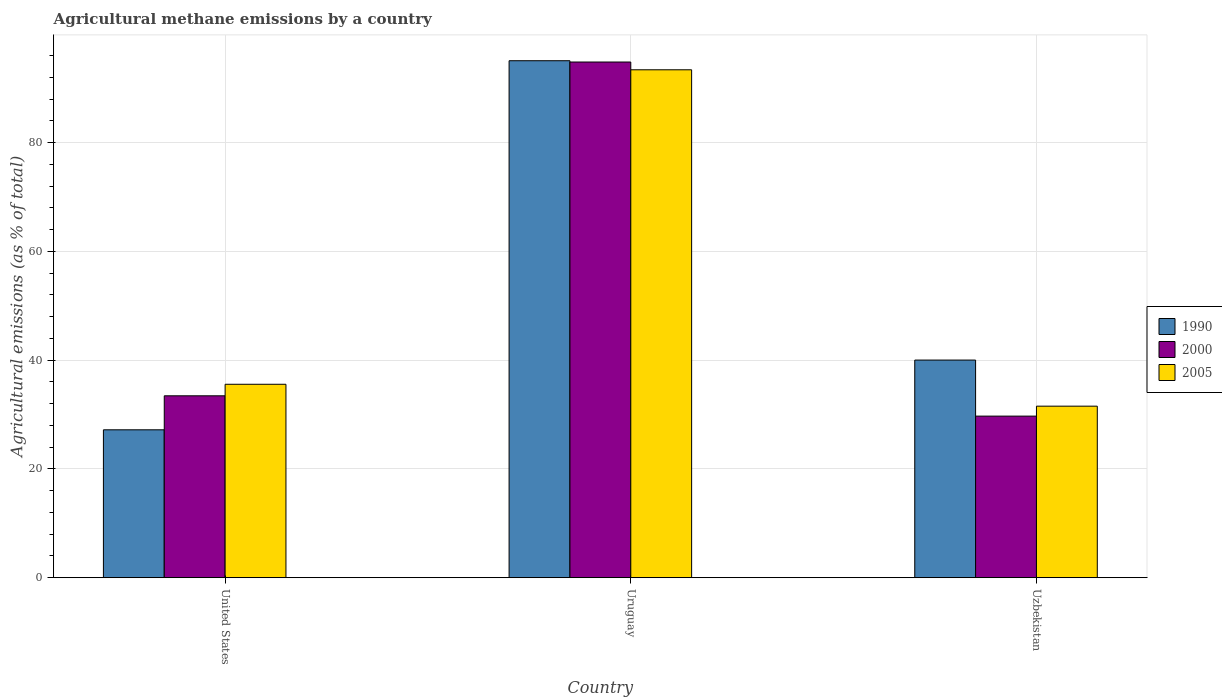Are the number of bars per tick equal to the number of legend labels?
Your answer should be compact. Yes. Are the number of bars on each tick of the X-axis equal?
Provide a succinct answer. Yes. How many bars are there on the 3rd tick from the left?
Your response must be concise. 3. How many bars are there on the 2nd tick from the right?
Your answer should be compact. 3. What is the label of the 2nd group of bars from the left?
Keep it short and to the point. Uruguay. What is the amount of agricultural methane emitted in 2005 in Uzbekistan?
Provide a succinct answer. 31.54. Across all countries, what is the maximum amount of agricultural methane emitted in 1990?
Offer a terse response. 95.06. Across all countries, what is the minimum amount of agricultural methane emitted in 2005?
Offer a terse response. 31.54. In which country was the amount of agricultural methane emitted in 1990 maximum?
Your response must be concise. Uruguay. In which country was the amount of agricultural methane emitted in 1990 minimum?
Offer a very short reply. United States. What is the total amount of agricultural methane emitted in 1990 in the graph?
Provide a short and direct response. 162.27. What is the difference between the amount of agricultural methane emitted in 1990 in United States and that in Uzbekistan?
Your answer should be very brief. -12.82. What is the difference between the amount of agricultural methane emitted in 2005 in United States and the amount of agricultural methane emitted in 2000 in Uzbekistan?
Offer a terse response. 5.85. What is the average amount of agricultural methane emitted in 1990 per country?
Your answer should be compact. 54.09. What is the difference between the amount of agricultural methane emitted of/in 2000 and amount of agricultural methane emitted of/in 1990 in Uzbekistan?
Ensure brevity in your answer.  -10.31. In how many countries, is the amount of agricultural methane emitted in 2000 greater than 28 %?
Offer a terse response. 3. What is the ratio of the amount of agricultural methane emitted in 2000 in United States to that in Uruguay?
Your answer should be compact. 0.35. Is the amount of agricultural methane emitted in 2000 in United States less than that in Uzbekistan?
Provide a succinct answer. No. What is the difference between the highest and the second highest amount of agricultural methane emitted in 2005?
Offer a very short reply. -57.82. What is the difference between the highest and the lowest amount of agricultural methane emitted in 1990?
Offer a terse response. 67.86. In how many countries, is the amount of agricultural methane emitted in 2000 greater than the average amount of agricultural methane emitted in 2000 taken over all countries?
Offer a very short reply. 1. Is the sum of the amount of agricultural methane emitted in 1990 in United States and Uzbekistan greater than the maximum amount of agricultural methane emitted in 2000 across all countries?
Make the answer very short. No. What does the 3rd bar from the left in United States represents?
Give a very brief answer. 2005. Is it the case that in every country, the sum of the amount of agricultural methane emitted in 2005 and amount of agricultural methane emitted in 1990 is greater than the amount of agricultural methane emitted in 2000?
Offer a terse response. Yes. How many bars are there?
Keep it short and to the point. 9. Are all the bars in the graph horizontal?
Give a very brief answer. No. What is the difference between two consecutive major ticks on the Y-axis?
Ensure brevity in your answer.  20. Are the values on the major ticks of Y-axis written in scientific E-notation?
Provide a succinct answer. No. Does the graph contain any zero values?
Provide a short and direct response. No. How are the legend labels stacked?
Offer a terse response. Vertical. What is the title of the graph?
Your answer should be very brief. Agricultural methane emissions by a country. Does "1962" appear as one of the legend labels in the graph?
Offer a very short reply. No. What is the label or title of the Y-axis?
Make the answer very short. Agricultural emissions (as % of total). What is the Agricultural emissions (as % of total) in 1990 in United States?
Your response must be concise. 27.19. What is the Agricultural emissions (as % of total) in 2000 in United States?
Offer a very short reply. 33.45. What is the Agricultural emissions (as % of total) of 2005 in United States?
Offer a terse response. 35.56. What is the Agricultural emissions (as % of total) in 1990 in Uruguay?
Ensure brevity in your answer.  95.06. What is the Agricultural emissions (as % of total) in 2000 in Uruguay?
Ensure brevity in your answer.  94.82. What is the Agricultural emissions (as % of total) in 2005 in Uruguay?
Provide a short and direct response. 93.39. What is the Agricultural emissions (as % of total) of 1990 in Uzbekistan?
Offer a very short reply. 40.02. What is the Agricultural emissions (as % of total) in 2000 in Uzbekistan?
Provide a succinct answer. 29.71. What is the Agricultural emissions (as % of total) of 2005 in Uzbekistan?
Give a very brief answer. 31.54. Across all countries, what is the maximum Agricultural emissions (as % of total) in 1990?
Offer a very short reply. 95.06. Across all countries, what is the maximum Agricultural emissions (as % of total) of 2000?
Provide a succinct answer. 94.82. Across all countries, what is the maximum Agricultural emissions (as % of total) in 2005?
Your answer should be compact. 93.39. Across all countries, what is the minimum Agricultural emissions (as % of total) in 1990?
Make the answer very short. 27.19. Across all countries, what is the minimum Agricultural emissions (as % of total) in 2000?
Keep it short and to the point. 29.71. Across all countries, what is the minimum Agricultural emissions (as % of total) of 2005?
Keep it short and to the point. 31.54. What is the total Agricultural emissions (as % of total) in 1990 in the graph?
Give a very brief answer. 162.27. What is the total Agricultural emissions (as % of total) in 2000 in the graph?
Ensure brevity in your answer.  157.97. What is the total Agricultural emissions (as % of total) of 2005 in the graph?
Offer a very short reply. 160.5. What is the difference between the Agricultural emissions (as % of total) in 1990 in United States and that in Uruguay?
Your answer should be very brief. -67.86. What is the difference between the Agricultural emissions (as % of total) of 2000 in United States and that in Uruguay?
Offer a terse response. -61.37. What is the difference between the Agricultural emissions (as % of total) of 2005 in United States and that in Uruguay?
Your answer should be very brief. -57.82. What is the difference between the Agricultural emissions (as % of total) in 1990 in United States and that in Uzbekistan?
Your response must be concise. -12.82. What is the difference between the Agricultural emissions (as % of total) of 2000 in United States and that in Uzbekistan?
Make the answer very short. 3.73. What is the difference between the Agricultural emissions (as % of total) of 2005 in United States and that in Uzbekistan?
Your response must be concise. 4.02. What is the difference between the Agricultural emissions (as % of total) of 1990 in Uruguay and that in Uzbekistan?
Your answer should be compact. 55.04. What is the difference between the Agricultural emissions (as % of total) in 2000 in Uruguay and that in Uzbekistan?
Your answer should be very brief. 65.11. What is the difference between the Agricultural emissions (as % of total) in 2005 in Uruguay and that in Uzbekistan?
Offer a very short reply. 61.85. What is the difference between the Agricultural emissions (as % of total) in 1990 in United States and the Agricultural emissions (as % of total) in 2000 in Uruguay?
Make the answer very short. -67.62. What is the difference between the Agricultural emissions (as % of total) in 1990 in United States and the Agricultural emissions (as % of total) in 2005 in Uruguay?
Give a very brief answer. -66.19. What is the difference between the Agricultural emissions (as % of total) in 2000 in United States and the Agricultural emissions (as % of total) in 2005 in Uruguay?
Your answer should be very brief. -59.94. What is the difference between the Agricultural emissions (as % of total) of 1990 in United States and the Agricultural emissions (as % of total) of 2000 in Uzbekistan?
Give a very brief answer. -2.52. What is the difference between the Agricultural emissions (as % of total) of 1990 in United States and the Agricultural emissions (as % of total) of 2005 in Uzbekistan?
Provide a short and direct response. -4.35. What is the difference between the Agricultural emissions (as % of total) in 2000 in United States and the Agricultural emissions (as % of total) in 2005 in Uzbekistan?
Keep it short and to the point. 1.9. What is the difference between the Agricultural emissions (as % of total) of 1990 in Uruguay and the Agricultural emissions (as % of total) of 2000 in Uzbekistan?
Provide a succinct answer. 65.35. What is the difference between the Agricultural emissions (as % of total) in 1990 in Uruguay and the Agricultural emissions (as % of total) in 2005 in Uzbekistan?
Keep it short and to the point. 63.51. What is the difference between the Agricultural emissions (as % of total) of 2000 in Uruguay and the Agricultural emissions (as % of total) of 2005 in Uzbekistan?
Give a very brief answer. 63.28. What is the average Agricultural emissions (as % of total) of 1990 per country?
Give a very brief answer. 54.09. What is the average Agricultural emissions (as % of total) of 2000 per country?
Give a very brief answer. 52.66. What is the average Agricultural emissions (as % of total) in 2005 per country?
Provide a succinct answer. 53.5. What is the difference between the Agricultural emissions (as % of total) in 1990 and Agricultural emissions (as % of total) in 2000 in United States?
Provide a succinct answer. -6.25. What is the difference between the Agricultural emissions (as % of total) of 1990 and Agricultural emissions (as % of total) of 2005 in United States?
Keep it short and to the point. -8.37. What is the difference between the Agricultural emissions (as % of total) in 2000 and Agricultural emissions (as % of total) in 2005 in United States?
Your answer should be very brief. -2.12. What is the difference between the Agricultural emissions (as % of total) in 1990 and Agricultural emissions (as % of total) in 2000 in Uruguay?
Keep it short and to the point. 0.24. What is the difference between the Agricultural emissions (as % of total) of 1990 and Agricultural emissions (as % of total) of 2005 in Uruguay?
Provide a short and direct response. 1.67. What is the difference between the Agricultural emissions (as % of total) in 2000 and Agricultural emissions (as % of total) in 2005 in Uruguay?
Your response must be concise. 1.43. What is the difference between the Agricultural emissions (as % of total) of 1990 and Agricultural emissions (as % of total) of 2000 in Uzbekistan?
Your answer should be compact. 10.31. What is the difference between the Agricultural emissions (as % of total) of 1990 and Agricultural emissions (as % of total) of 2005 in Uzbekistan?
Provide a succinct answer. 8.47. What is the difference between the Agricultural emissions (as % of total) in 2000 and Agricultural emissions (as % of total) in 2005 in Uzbekistan?
Your answer should be compact. -1.83. What is the ratio of the Agricultural emissions (as % of total) of 1990 in United States to that in Uruguay?
Your answer should be compact. 0.29. What is the ratio of the Agricultural emissions (as % of total) of 2000 in United States to that in Uruguay?
Offer a terse response. 0.35. What is the ratio of the Agricultural emissions (as % of total) in 2005 in United States to that in Uruguay?
Your answer should be very brief. 0.38. What is the ratio of the Agricultural emissions (as % of total) of 1990 in United States to that in Uzbekistan?
Make the answer very short. 0.68. What is the ratio of the Agricultural emissions (as % of total) in 2000 in United States to that in Uzbekistan?
Your answer should be very brief. 1.13. What is the ratio of the Agricultural emissions (as % of total) in 2005 in United States to that in Uzbekistan?
Your answer should be compact. 1.13. What is the ratio of the Agricultural emissions (as % of total) in 1990 in Uruguay to that in Uzbekistan?
Give a very brief answer. 2.38. What is the ratio of the Agricultural emissions (as % of total) of 2000 in Uruguay to that in Uzbekistan?
Your answer should be very brief. 3.19. What is the ratio of the Agricultural emissions (as % of total) in 2005 in Uruguay to that in Uzbekistan?
Your answer should be compact. 2.96. What is the difference between the highest and the second highest Agricultural emissions (as % of total) of 1990?
Provide a short and direct response. 55.04. What is the difference between the highest and the second highest Agricultural emissions (as % of total) of 2000?
Keep it short and to the point. 61.37. What is the difference between the highest and the second highest Agricultural emissions (as % of total) in 2005?
Offer a terse response. 57.82. What is the difference between the highest and the lowest Agricultural emissions (as % of total) in 1990?
Offer a terse response. 67.86. What is the difference between the highest and the lowest Agricultural emissions (as % of total) in 2000?
Give a very brief answer. 65.11. What is the difference between the highest and the lowest Agricultural emissions (as % of total) of 2005?
Ensure brevity in your answer.  61.85. 